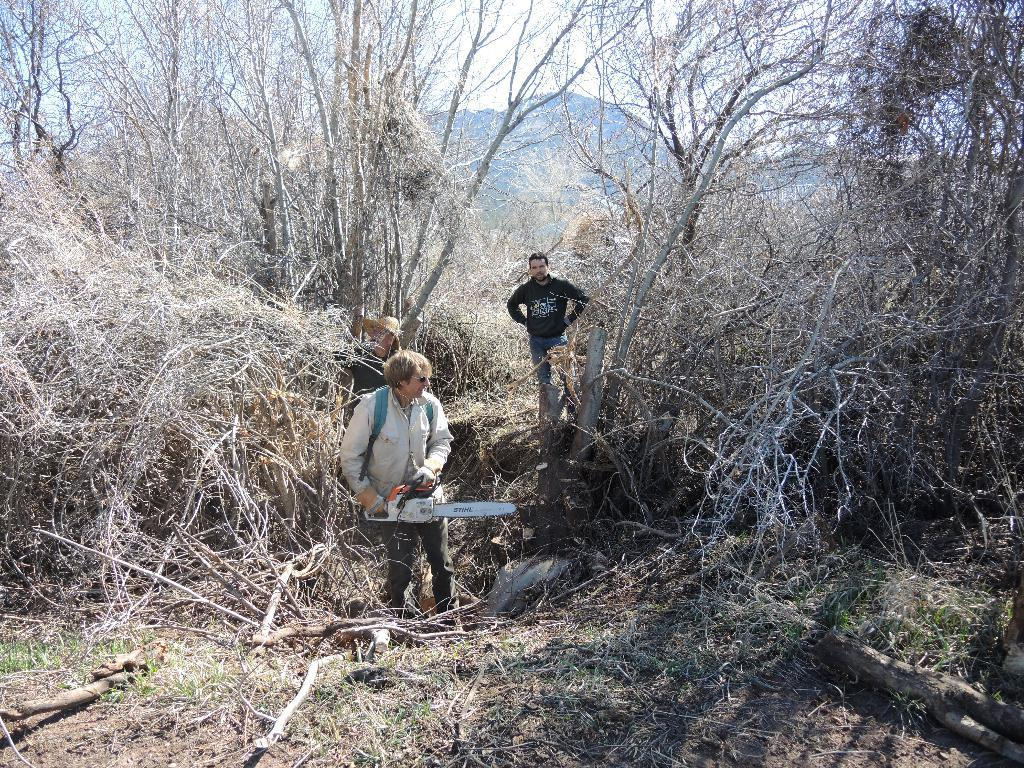How many people are present in the image? There are three people standing in the image. What can be seen in the background of the image? There are trees and a mountain in the background of the image. What type of argument is taking place between the people in the image? There is no indication of an argument in the image; the three people are simply standing. 